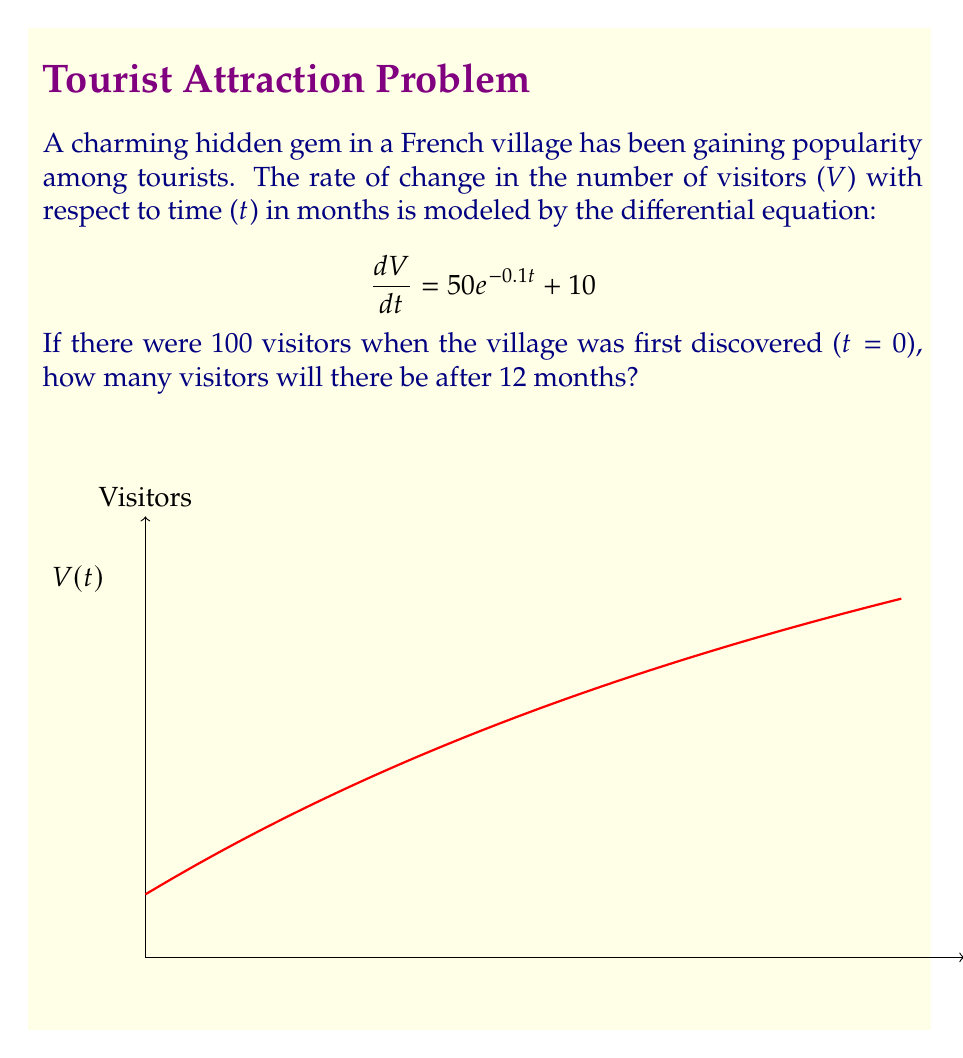Teach me how to tackle this problem. Let's solve this step-by-step:

1) We have the differential equation: $$\frac{dV}{dt} = 50e^{-0.1t} + 10$$

2) To find V(t), we need to integrate both sides:
   $$V = \int (50e^{-0.1t} + 10) dt$$

3) Integrating:
   $$V = -500e^{-0.1t} + 10t + C$$

4) We know that when t = 0, V = 100. Let's use this to find C:
   $$100 = -500e^{-0.1(0)} + 10(0) + C$$
   $$100 = -500 + C$$
   $$C = 600$$

5) So our full equation for V(t) is:
   $$V(t) = -500e^{-0.1t} + 10t + 600$$

6) To find the number of visitors after 12 months, we plug in t = 12:
   $$V(12) = -500e^{-0.1(12)} + 10(12) + 600$$
   $$= -500e^{-1.2} + 120 + 600$$
   $$\approx -150.34 + 120 + 600$$
   $$\approx 569.66$$

7) Rounding to the nearest whole number (as we can't have fractional visitors):
   $$V(12) \approx 570$$
Answer: 570 visitors 